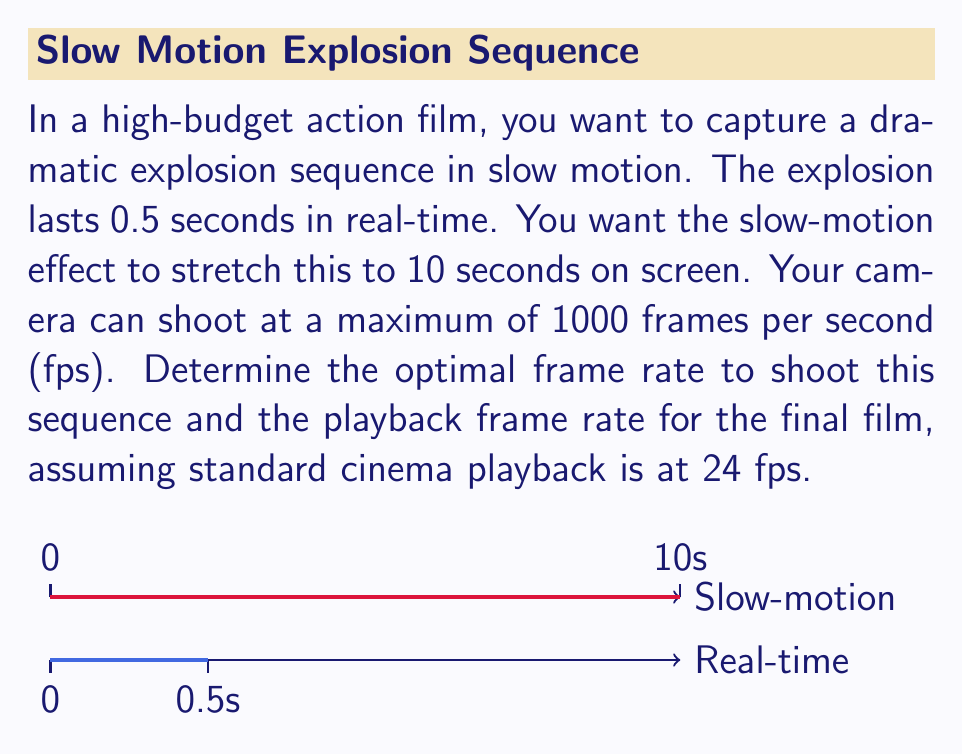Show me your answer to this math problem. Let's approach this step-by-step:

1) First, we need to calculate the slow-motion factor:
   $$\text{Slow-motion factor} = \frac{\text{Slow-motion duration}}{\text{Real-time duration}} = \frac{10\text{ s}}{0.5\text{ s}} = 20$$

2) This means each frame in real-time needs to be stretched to 20 frames in slow-motion.

3) To determine the optimal frame rate for shooting, we need to consider:
   - The maximum camera capability (1000 fps)
   - The desired slow-motion smoothness

4) The higher the shooting frame rate, the smoother the slow-motion will be. However, we don't necessarily need to use the maximum 1000 fps.

5) A good rule of thumb is to match or exceed the number of frames that will be in the final slow-motion sequence:
   $$\text{Frames in slow-motion} = 10\text{ s} \times 24\text{ fps} = 240\text{ frames}$$

6) To capture 240 frames in 0.5 seconds, we need:
   $$\text{Optimal frame rate} = \frac{240\text{ frames}}{0.5\text{ s}} = 480\text{ fps}$$

7) This is within the camera's capabilities and will provide smooth slow-motion.

8) For playback, we use the standard cinema rate of 24 fps.
Answer: Shoot at 480 fps, play back at 24 fps 